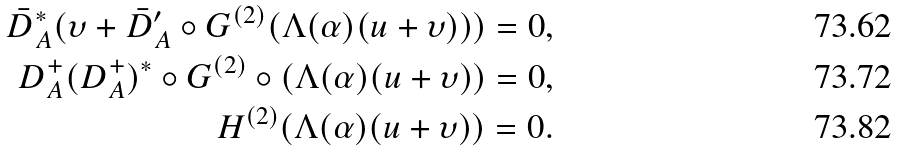<formula> <loc_0><loc_0><loc_500><loc_500>\bar { D } ^ { * } _ { A } ( \upsilon + \bar { D } _ { A } ^ { \prime } \circ G ^ { ( 2 ) } ( \Lambda ( \alpha ) ( u + \upsilon ) ) ) = 0 , \\ { D } _ { A } ^ { + } ( D _ { A } ^ { + } ) ^ { * } \circ G ^ { ( 2 ) } \circ ( \Lambda ( \alpha ) ( u + \upsilon ) ) = 0 , \\ H ^ { ( 2 ) } ( \Lambda ( \alpha ) ( u + \upsilon ) ) = 0 .</formula> 